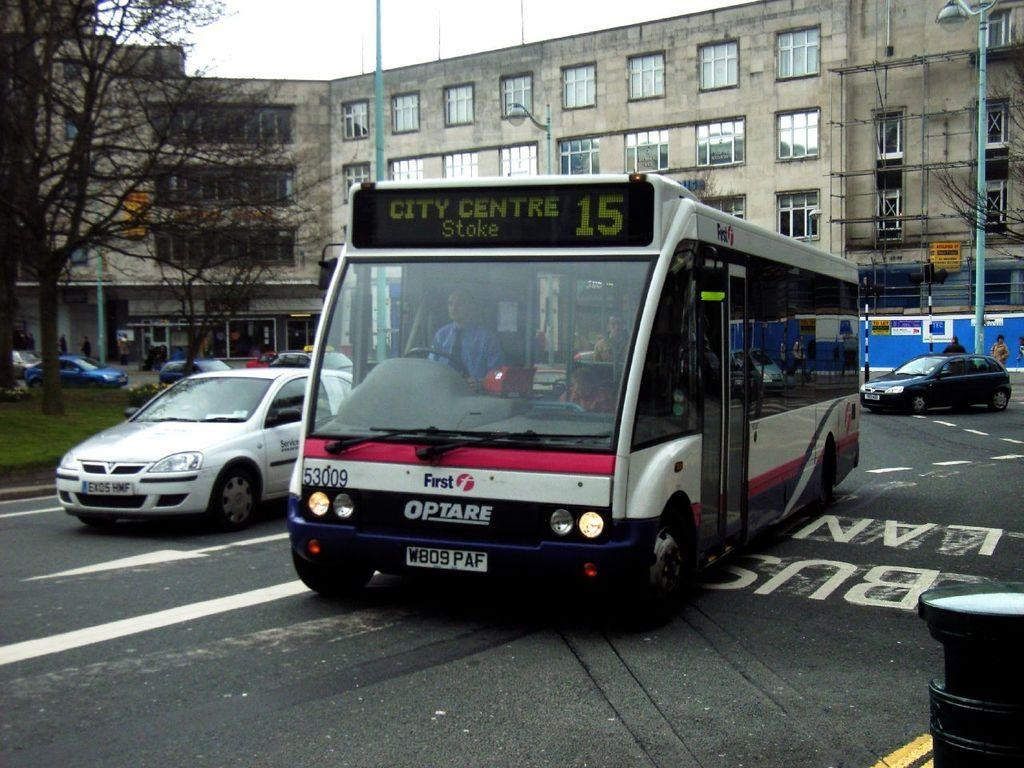What can be seen on the road in the image? There are vehicles on the road in the image. What type of vegetation is visible in the image? Grass and trees are present in the image. What structures are in the image? Poles, posters, and buildings with windows are in the image. Who or what is present in the image? There are people and objects in the image. What is visible in the background of the image? The sky is visible in the background of the image. What color is the crayon used to draw the peace symbol in the image? There is no crayon or peace symbol present in the image. How much powder is needed to cover the objects in the image? There is no mention of powder in the image, so it cannot be determined how much would be needed to cover the objects. 